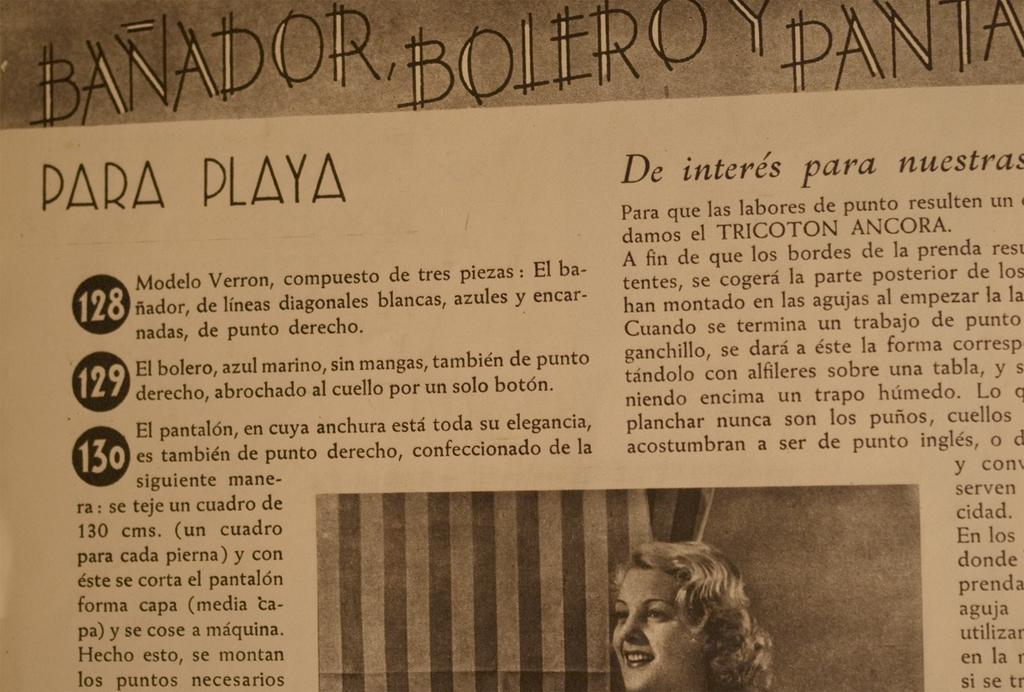What is the main object in the image? There is a paper in the image. What can be found on the paper? There is printed text on the paper. Is there any image or illustration on the paper? Yes, a woman's face is present at the bottom of the paper. What type of baseball patch can be seen on the woman's face in the image? There is no baseball patch or any reference to baseball in the image. The image only features a paper with printed text and a woman's face at the bottom. 